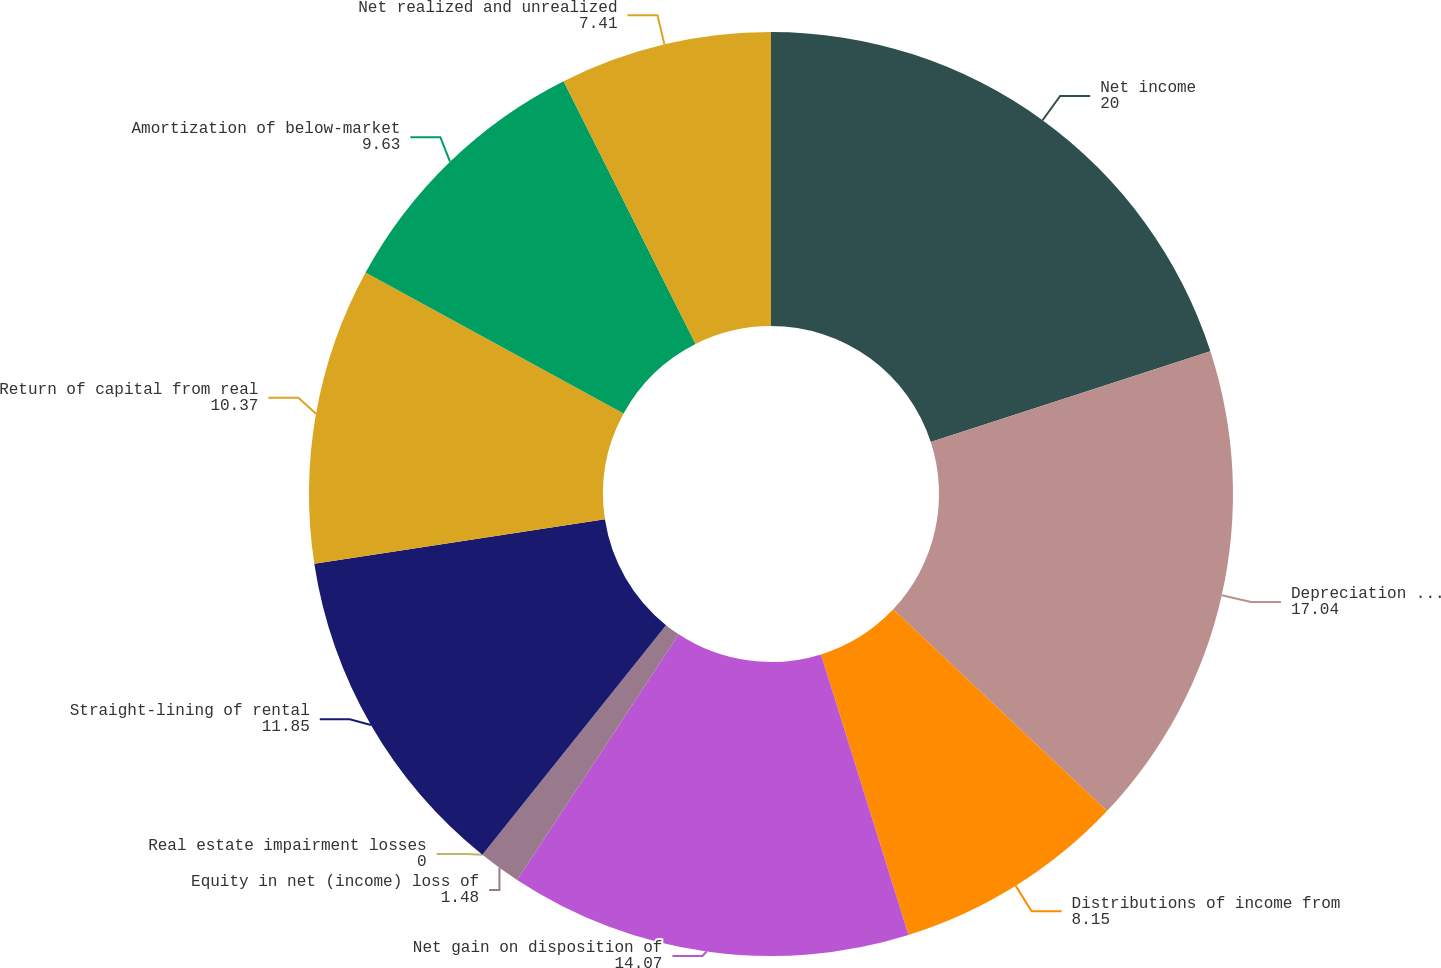<chart> <loc_0><loc_0><loc_500><loc_500><pie_chart><fcel>Net income<fcel>Depreciation and amortization<fcel>Distributions of income from<fcel>Net gain on disposition of<fcel>Equity in net (income) loss of<fcel>Real estate impairment losses<fcel>Straight-lining of rental<fcel>Return of capital from real<fcel>Amortization of below-market<fcel>Net realized and unrealized<nl><fcel>20.0%<fcel>17.04%<fcel>8.15%<fcel>14.07%<fcel>1.48%<fcel>0.0%<fcel>11.85%<fcel>10.37%<fcel>9.63%<fcel>7.41%<nl></chart> 